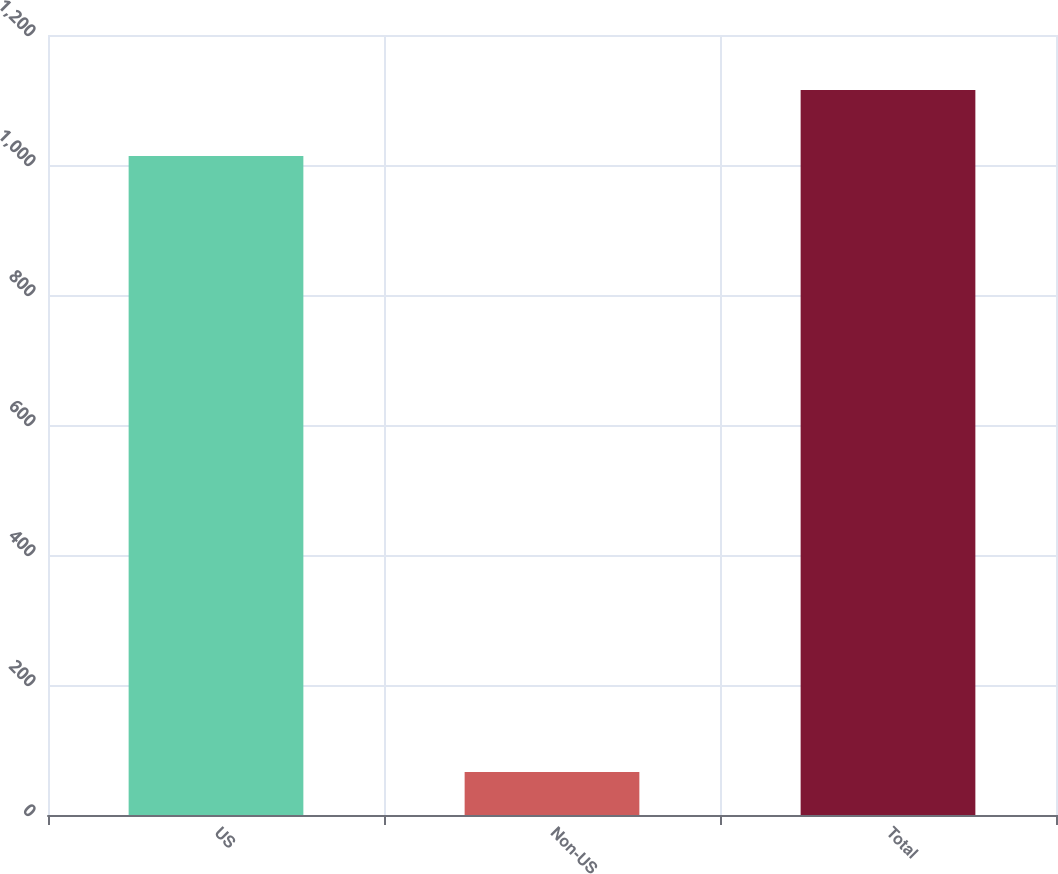<chart> <loc_0><loc_0><loc_500><loc_500><bar_chart><fcel>US<fcel>Non-US<fcel>Total<nl><fcel>1014<fcel>66<fcel>1115.4<nl></chart> 